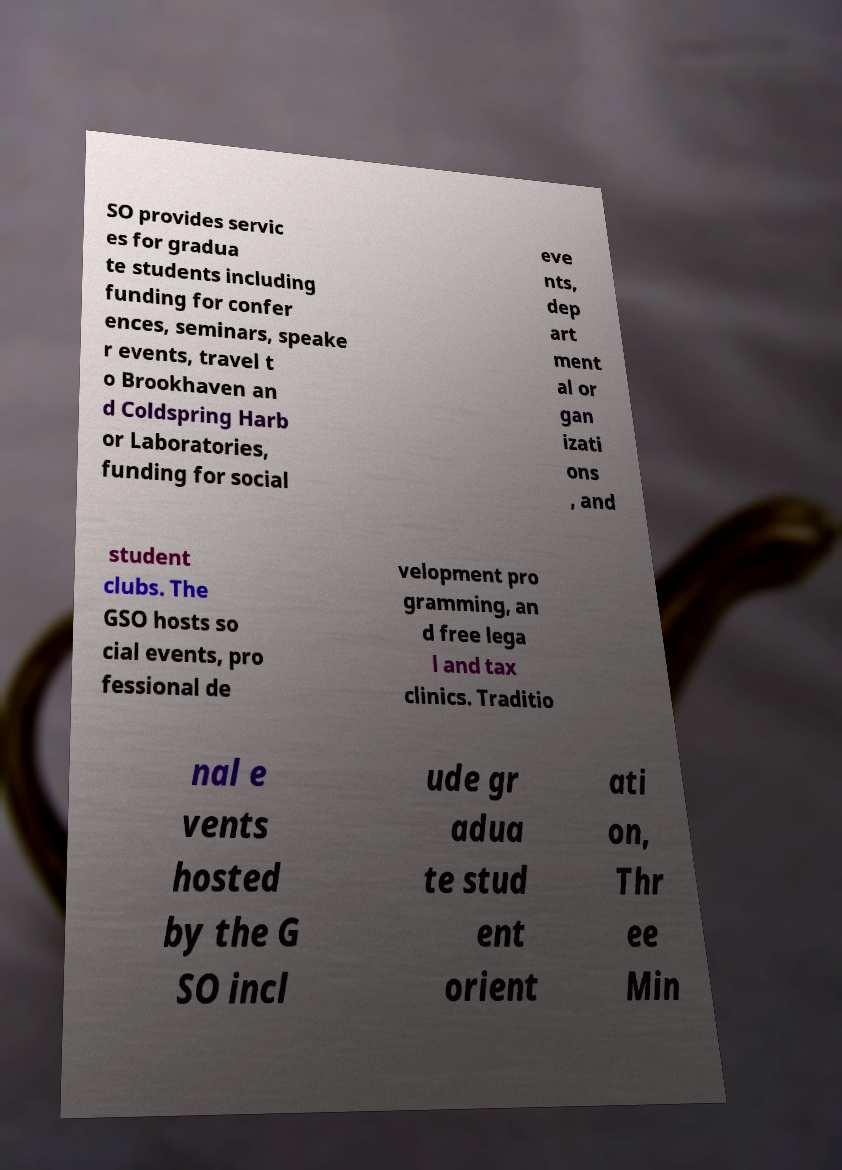Can you accurately transcribe the text from the provided image for me? SO provides servic es for gradua te students including funding for confer ences, seminars, speake r events, travel t o Brookhaven an d Coldspring Harb or Laboratories, funding for social eve nts, dep art ment al or gan izati ons , and student clubs. The GSO hosts so cial events, pro fessional de velopment pro gramming, an d free lega l and tax clinics. Traditio nal e vents hosted by the G SO incl ude gr adua te stud ent orient ati on, Thr ee Min 